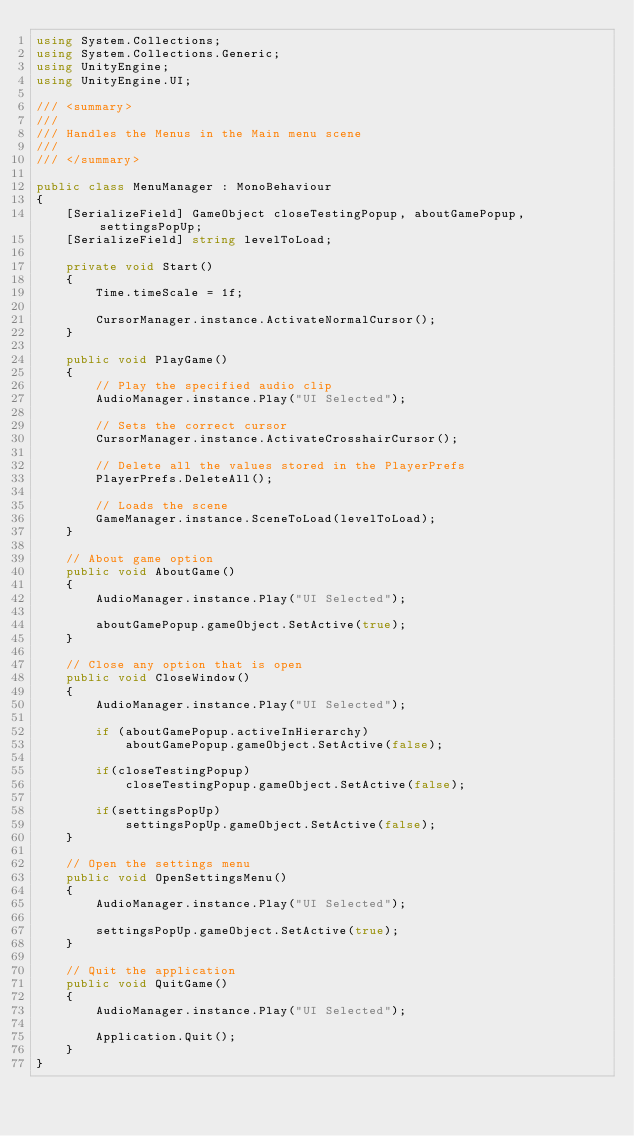Convert code to text. <code><loc_0><loc_0><loc_500><loc_500><_C#_>using System.Collections;
using System.Collections.Generic;
using UnityEngine;
using UnityEngine.UI;

/// <summary>
/// 
/// Handles the Menus in the Main menu scene
/// 
/// </summary>

public class MenuManager : MonoBehaviour
{
    [SerializeField] GameObject closeTestingPopup, aboutGamePopup, settingsPopUp;
    [SerializeField] string levelToLoad;

    private void Start()
    {
        Time.timeScale = 1f;

        CursorManager.instance.ActivateNormalCursor();
    }

    public void PlayGame()
    {
        // Play the specified audio clip
        AudioManager.instance.Play("UI Selected");
        
        // Sets the correct cursor
        CursorManager.instance.ActivateCrosshairCursor();

        // Delete all the values stored in the PlayerPrefs
        PlayerPrefs.DeleteAll();
        
        // Loads the scene
        GameManager.instance.SceneToLoad(levelToLoad);
    }

    // About game option
    public void AboutGame()
    {
        AudioManager.instance.Play("UI Selected");

        aboutGamePopup.gameObject.SetActive(true);
    }

    // Close any option that is open
    public void CloseWindow()
    {
        AudioManager.instance.Play("UI Selected");

        if (aboutGamePopup.activeInHierarchy)
            aboutGamePopup.gameObject.SetActive(false);

        if(closeTestingPopup)
            closeTestingPopup.gameObject.SetActive(false);
    
        if(settingsPopUp)
            settingsPopUp.gameObject.SetActive(false);
    }

    // Open the settings menu
    public void OpenSettingsMenu()
    {
        AudioManager.instance.Play("UI Selected");

        settingsPopUp.gameObject.SetActive(true);
    }

    // Quit the application
    public void QuitGame()
    {
        AudioManager.instance.Play("UI Selected");

        Application.Quit();
    }
}
</code> 